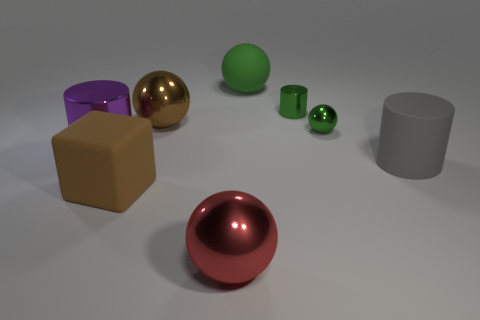What number of spheres are either tiny shiny things or large brown matte things?
Your response must be concise. 1. There is a green matte object; is it the same shape as the green shiny thing that is in front of the big brown ball?
Your answer should be compact. Yes. How many purple blocks have the same size as the brown block?
Give a very brief answer. 0. There is a brown thing to the right of the large brown rubber cube; is its shape the same as the green shiny thing behind the brown metallic thing?
Give a very brief answer. No. There is a object that is the same color as the rubber block; what shape is it?
Offer a terse response. Sphere. There is a large object that is behind the large metallic ball to the left of the big red thing; what color is it?
Provide a short and direct response. Green. There is another small metal object that is the same shape as the purple shiny object; what color is it?
Offer a very short reply. Green. What size is the other green shiny object that is the same shape as the large green object?
Offer a terse response. Small. What is the large brown object in front of the big gray matte cylinder made of?
Your answer should be very brief. Rubber. Are there fewer big metal cylinders to the right of the large purple thing than blue spheres?
Your answer should be very brief. No. 